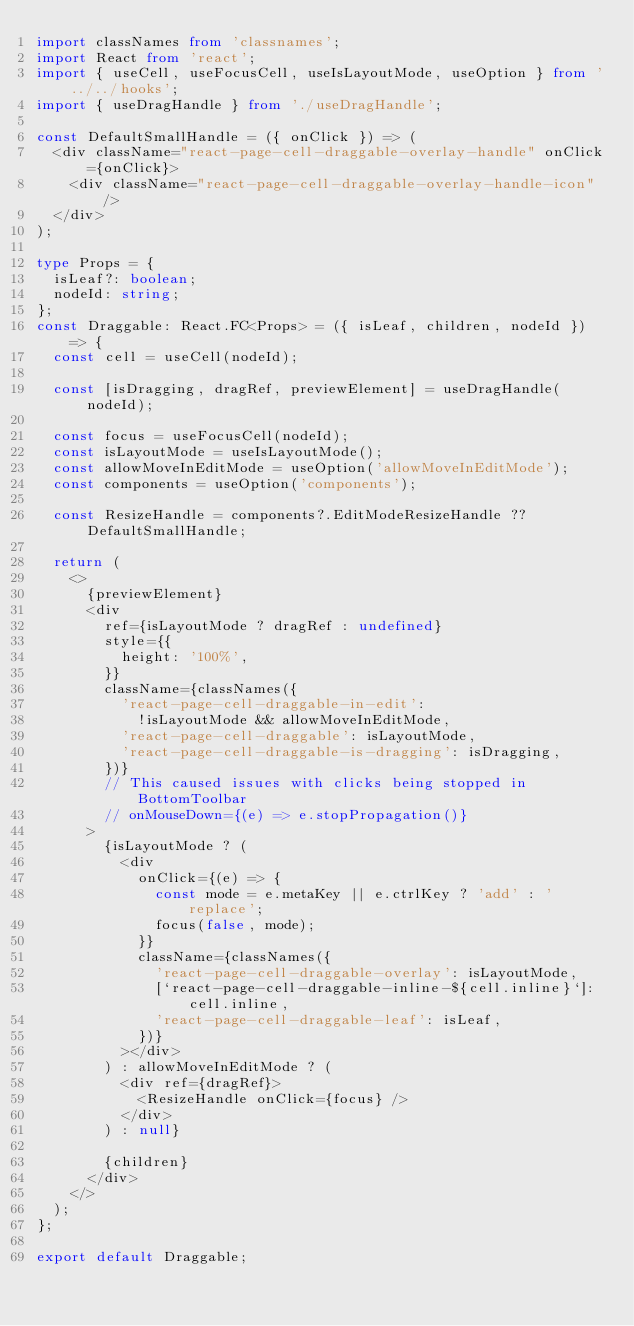Convert code to text. <code><loc_0><loc_0><loc_500><loc_500><_TypeScript_>import classNames from 'classnames';
import React from 'react';
import { useCell, useFocusCell, useIsLayoutMode, useOption } from '../../hooks';
import { useDragHandle } from './useDragHandle';

const DefaultSmallHandle = ({ onClick }) => (
  <div className="react-page-cell-draggable-overlay-handle" onClick={onClick}>
    <div className="react-page-cell-draggable-overlay-handle-icon" />
  </div>
);

type Props = {
  isLeaf?: boolean;
  nodeId: string;
};
const Draggable: React.FC<Props> = ({ isLeaf, children, nodeId }) => {
  const cell = useCell(nodeId);

  const [isDragging, dragRef, previewElement] = useDragHandle(nodeId);

  const focus = useFocusCell(nodeId);
  const isLayoutMode = useIsLayoutMode();
  const allowMoveInEditMode = useOption('allowMoveInEditMode');
  const components = useOption('components');

  const ResizeHandle = components?.EditModeResizeHandle ?? DefaultSmallHandle;

  return (
    <>
      {previewElement}
      <div
        ref={isLayoutMode ? dragRef : undefined}
        style={{
          height: '100%',
        }}
        className={classNames({
          'react-page-cell-draggable-in-edit':
            !isLayoutMode && allowMoveInEditMode,
          'react-page-cell-draggable': isLayoutMode,
          'react-page-cell-draggable-is-dragging': isDragging,
        })}
        // This caused issues with clicks being stopped in BottomToolbar
        // onMouseDown={(e) => e.stopPropagation()}
      >
        {isLayoutMode ? (
          <div
            onClick={(e) => {
              const mode = e.metaKey || e.ctrlKey ? 'add' : 'replace';
              focus(false, mode);
            }}
            className={classNames({
              'react-page-cell-draggable-overlay': isLayoutMode,
              [`react-page-cell-draggable-inline-${cell.inline}`]: cell.inline,
              'react-page-cell-draggable-leaf': isLeaf,
            })}
          ></div>
        ) : allowMoveInEditMode ? (
          <div ref={dragRef}>
            <ResizeHandle onClick={focus} />
          </div>
        ) : null}

        {children}
      </div>
    </>
  );
};

export default Draggable;
</code> 